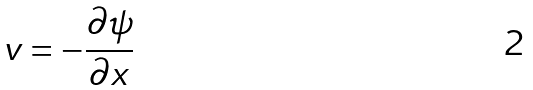<formula> <loc_0><loc_0><loc_500><loc_500>v = - \frac { \partial \psi } { \partial x }</formula> 